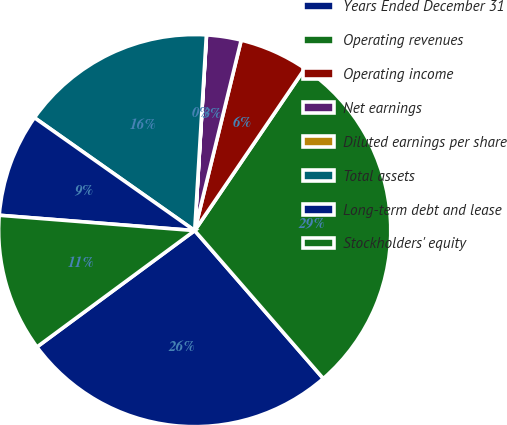Convert chart to OTSL. <chart><loc_0><loc_0><loc_500><loc_500><pie_chart><fcel>Years Ended December 31<fcel>Operating revenues<fcel>Operating income<fcel>Net earnings<fcel>Diluted earnings per share<fcel>Total assets<fcel>Long-term debt and lease<fcel>Stockholders' equity<nl><fcel>26.27%<fcel>29.11%<fcel>5.69%<fcel>2.85%<fcel>0.01%<fcel>16.18%<fcel>8.52%<fcel>11.36%<nl></chart> 